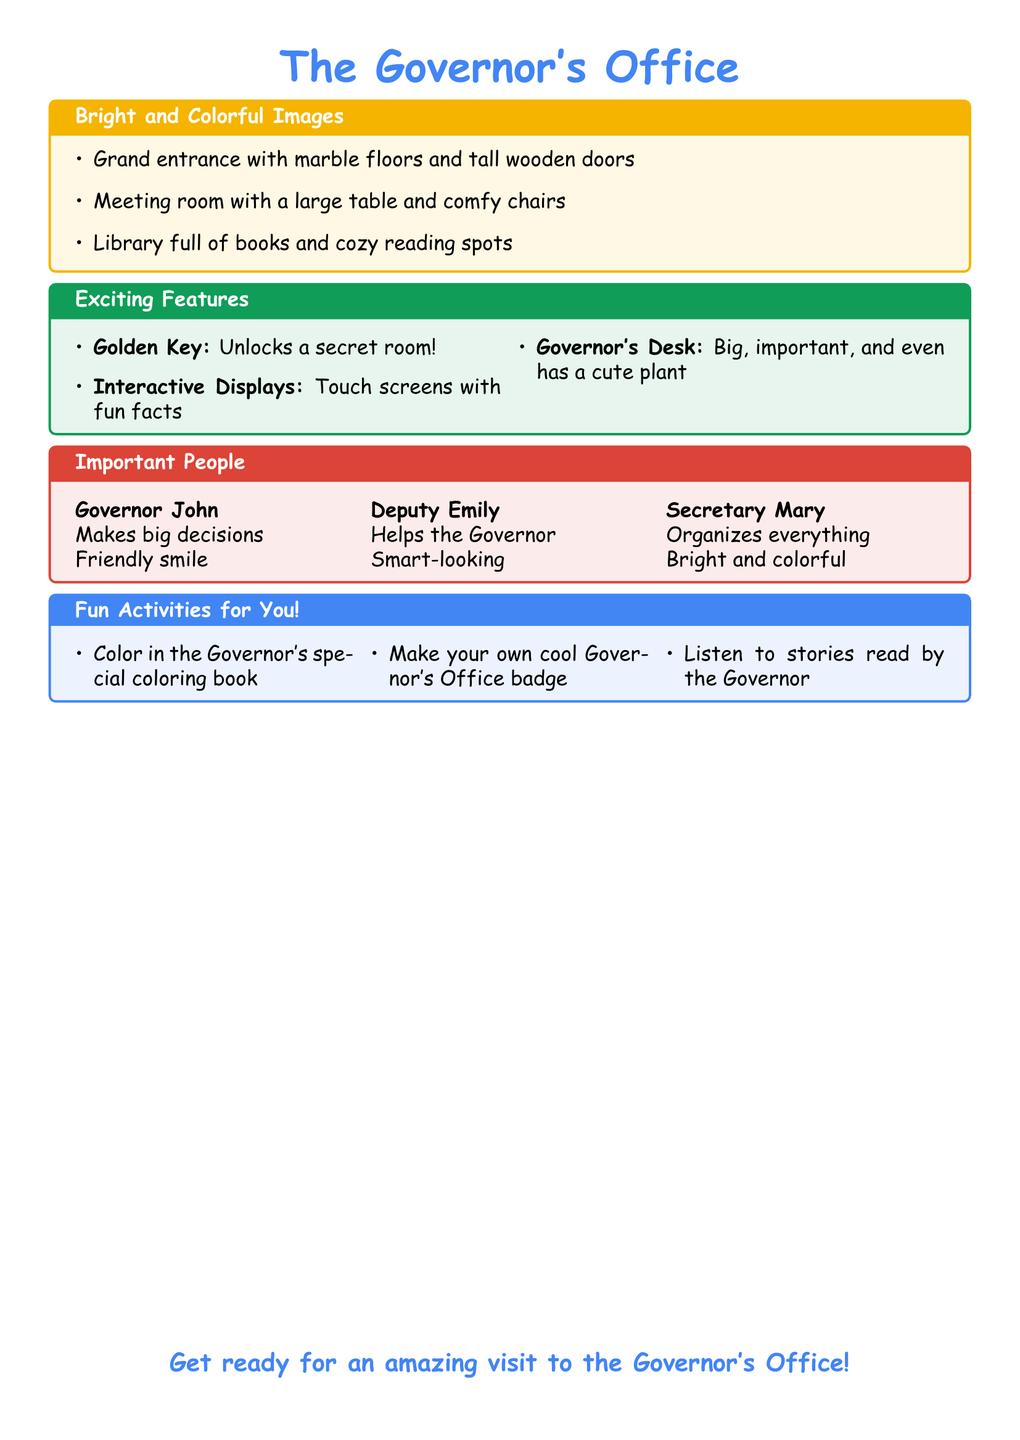What is the color of the title for the Governor's Office? The title color mentioned in the document is kidblue, which is used for the heading text.
Answer: kidblue What is one exciting feature of the Governor's Office? The document lists several exciting features, one of which is "Interactive Displays."
Answer: Interactive Displays Who is the Governor? The document specifies that the Governor is named John.
Answer: Governor John How many important people are mentioned? The document lists three important people associated with the Governor's Office.
Answer: three What can you do with the golden key? The golden key is mentioned to unlock a secret room in the Governor's Office.
Answer: unlocks a secret room What item is found on the Governor's desk? The document states that the Governor's desk has a cute plant.
Answer: cute plant What activity can you do with the Governor's special coloring book? The document mentions that you can color in it.
Answer: Color in How many comfy chairs are in the meeting room? The document does not specify the number of comfy chairs but mentions there are comfy chairs.
Answer: comfy chairs 